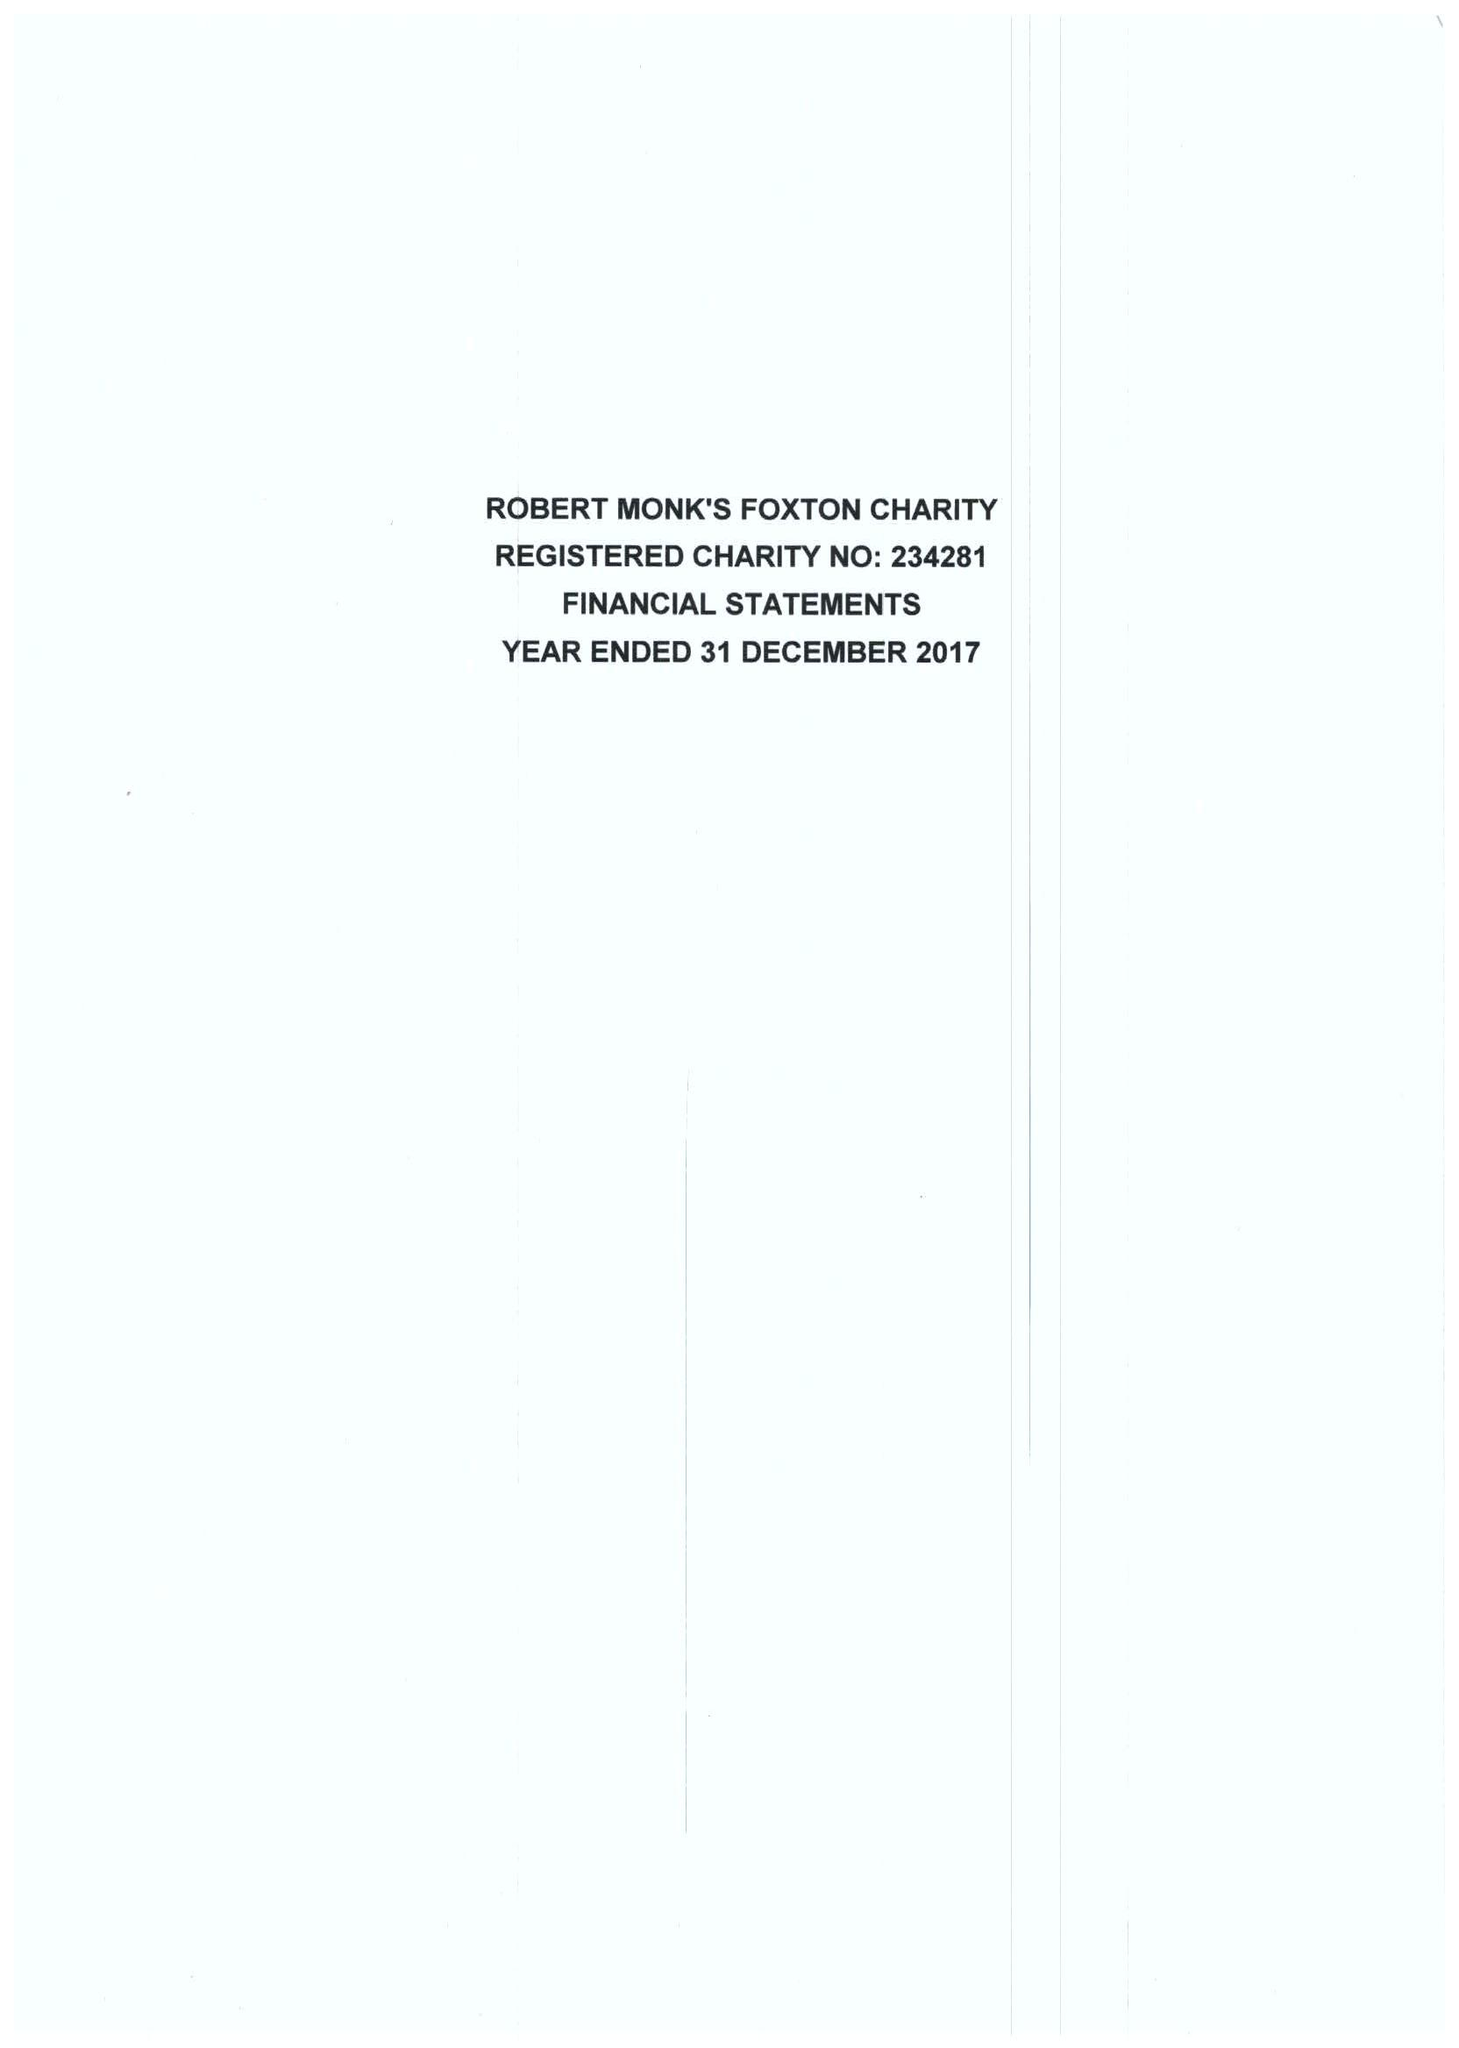What is the value for the report_date?
Answer the question using a single word or phrase. 2017-12-31 